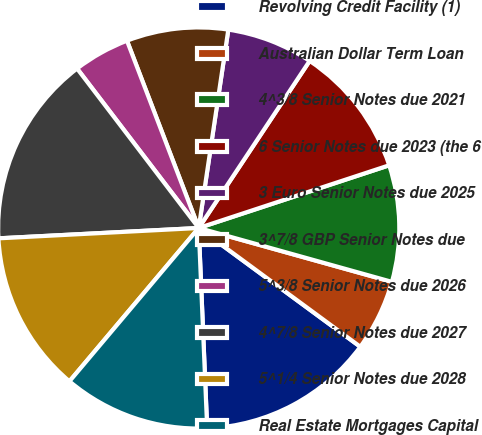Convert chart to OTSL. <chart><loc_0><loc_0><loc_500><loc_500><pie_chart><fcel>Revolving Credit Facility (1)<fcel>Australian Dollar Term Loan<fcel>4^3/8 Senior Notes due 2021<fcel>6 Senior Notes due 2023 (the 6<fcel>3 Euro Senior Notes due 2025<fcel>3^7/8 GBP Senior Notes due<fcel>5^3/8 Senior Notes due 2026<fcel>4^7/8 Senior Notes due 2027<fcel>5^1/4 Senior Notes due 2028<fcel>Real Estate Mortgages Capital<nl><fcel>14.24%<fcel>5.76%<fcel>9.39%<fcel>10.61%<fcel>6.97%<fcel>8.18%<fcel>4.55%<fcel>15.45%<fcel>13.03%<fcel>11.82%<nl></chart> 